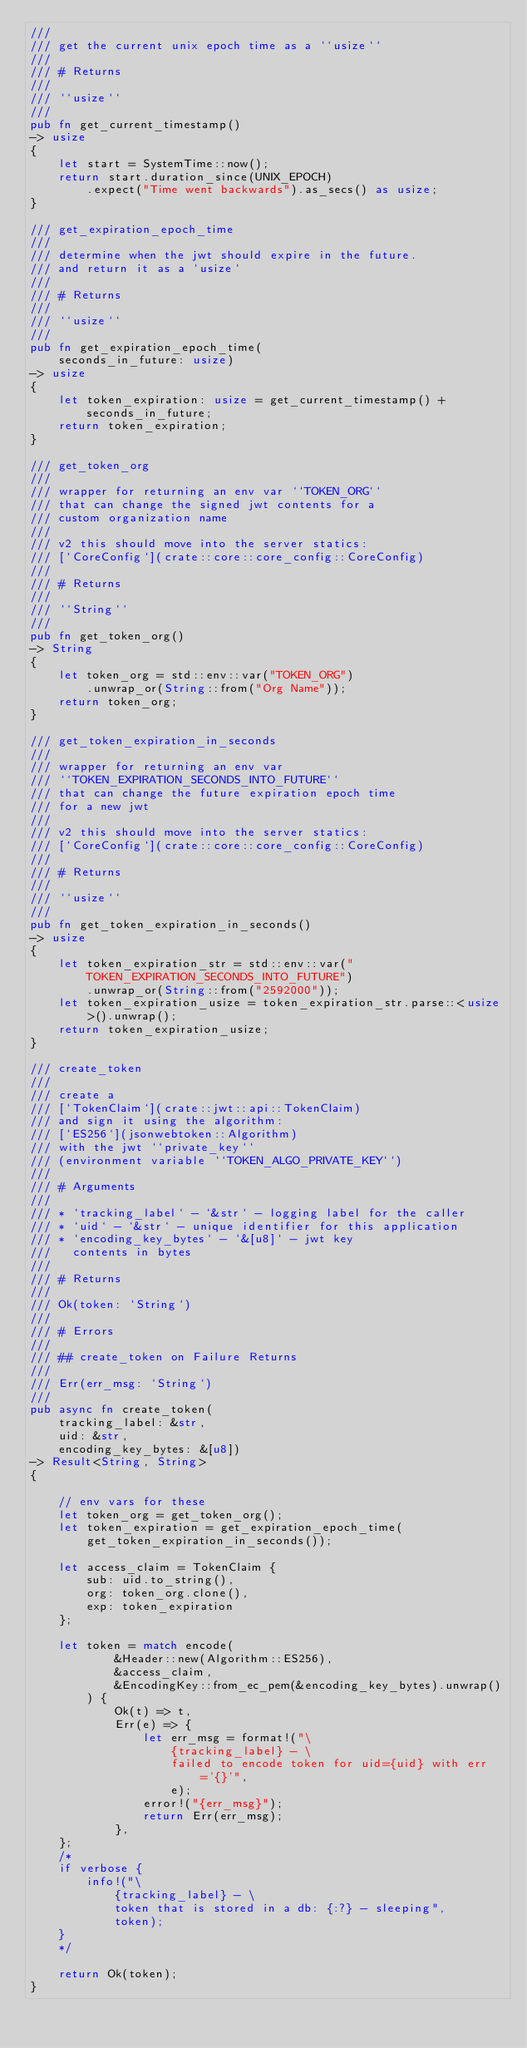Convert code to text. <code><loc_0><loc_0><loc_500><loc_500><_Rust_>///
/// get the current unix epoch time as a ``usize``
///
/// # Returns
///
/// ``usize``
///
pub fn get_current_timestamp()
-> usize
{
    let start = SystemTime::now();
    return start.duration_since(UNIX_EPOCH)
        .expect("Time went backwards").as_secs() as usize;
}

/// get_expiration_epoch_time
///
/// determine when the jwt should expire in the future.
/// and return it as a `usize`
///
/// # Returns
///
/// ``usize``
///
pub fn get_expiration_epoch_time(
    seconds_in_future: usize)
-> usize
{
    let token_expiration: usize = get_current_timestamp() + seconds_in_future;
    return token_expiration;
}

/// get_token_org
///
/// wrapper for returning an env var ``TOKEN_ORG``
/// that can change the signed jwt contents for a
/// custom organization name
///
/// v2 this should move into the server statics:
/// [`CoreConfig`](crate::core::core_config::CoreConfig)
///
/// # Returns
///
/// ``String``
///
pub fn get_token_org()
-> String
{
    let token_org = std::env::var("TOKEN_ORG")
        .unwrap_or(String::from("Org Name"));
    return token_org;
}

/// get_token_expiration_in_seconds
///
/// wrapper for returning an env var
/// ``TOKEN_EXPIRATION_SECONDS_INTO_FUTURE``
/// that can change the future expiration epoch time
/// for a new jwt
///
/// v2 this should move into the server statics:
/// [`CoreConfig`](crate::core::core_config::CoreConfig)
///
/// # Returns
///
/// ``usize``
///
pub fn get_token_expiration_in_seconds()
-> usize
{
    let token_expiration_str = std::env::var("TOKEN_EXPIRATION_SECONDS_INTO_FUTURE")
        .unwrap_or(String::from("2592000"));
    let token_expiration_usize = token_expiration_str.parse::<usize>().unwrap();
    return token_expiration_usize;
}

/// create_token
///
/// create a
/// [`TokenClaim`](crate::jwt::api::TokenClaim)
/// and sign it using the algorithm:
/// [`ES256`](jsonwebtoken::Algorithm)
/// with the jwt ``private_key``
/// (environment variable ``TOKEN_ALGO_PRIVATE_KEY``)
///
/// # Arguments
///
/// * `tracking_label` - `&str` - logging label for the caller
/// * `uid` - `&str` - unique identifier for this application
/// * `encoding_key_bytes` - `&[u8]` - jwt key
///   contents in bytes
///
/// # Returns
///
/// Ok(token: `String`)
///
/// # Errors
///
/// ## create_token on Failure Returns
///
/// Err(err_msg: `String`)
///
pub async fn create_token(
    tracking_label: &str,
    uid: &str,
    encoding_key_bytes: &[u8])
-> Result<String, String>
{

    // env vars for these
    let token_org = get_token_org();
    let token_expiration = get_expiration_epoch_time(
        get_token_expiration_in_seconds());

    let access_claim = TokenClaim {
        sub: uid.to_string(),
        org: token_org.clone(),
        exp: token_expiration
    };

    let token = match encode(
            &Header::new(Algorithm::ES256),
            &access_claim,
            &EncodingKey::from_ec_pem(&encoding_key_bytes).unwrap()
        ) {
            Ok(t) => t,
            Err(e) => {
                let err_msg = format!("\
                    {tracking_label} - \
                    failed to encode token for uid={uid} with err='{}'",
                    e);
                error!("{err_msg}");
                return Err(err_msg);
            },
    };
    /*
    if verbose {
        info!("\
            {tracking_label} - \
            token that is stored in a db: {:?} - sleeping",
            token);
    }
    */

    return Ok(token);
}
</code> 